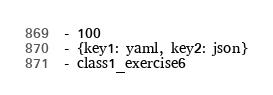Convert code to text. <code><loc_0><loc_0><loc_500><loc_500><_YAML_>- 100
- {key1: yaml, key2: json}
- class1_exercise6
</code> 